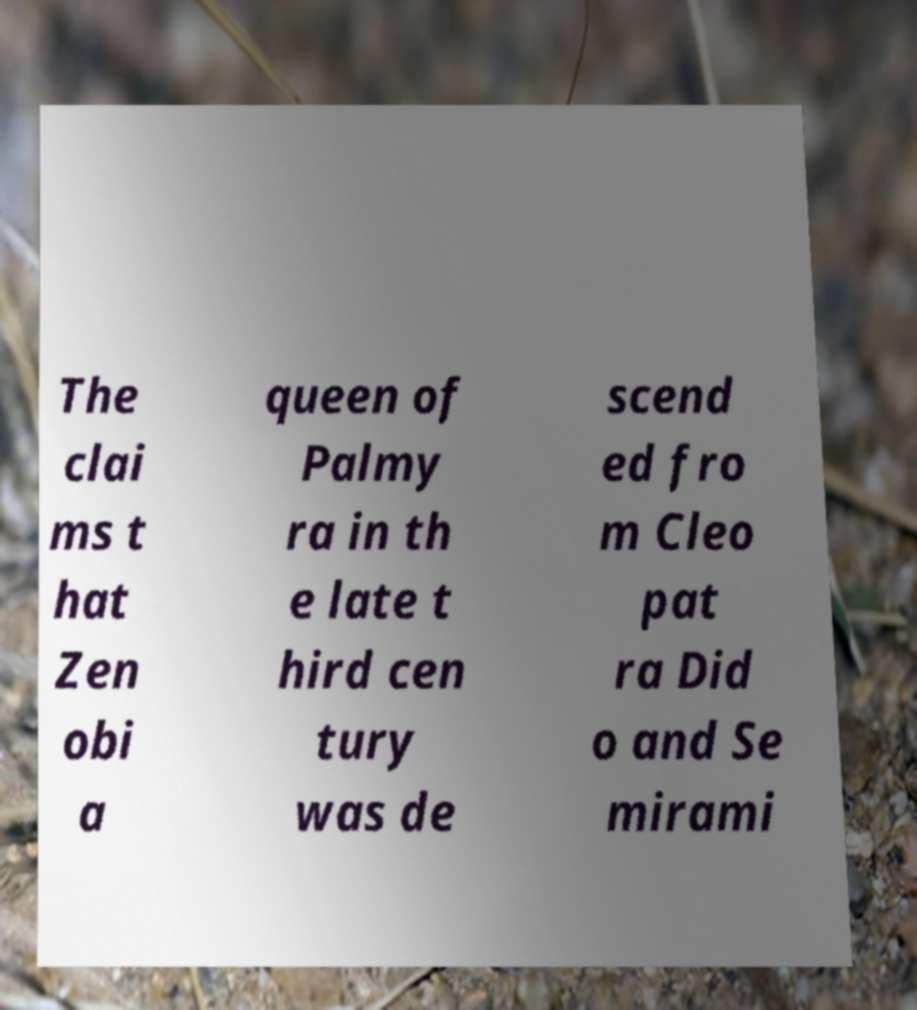Please read and relay the text visible in this image. What does it say? The clai ms t hat Zen obi a queen of Palmy ra in th e late t hird cen tury was de scend ed fro m Cleo pat ra Did o and Se mirami 